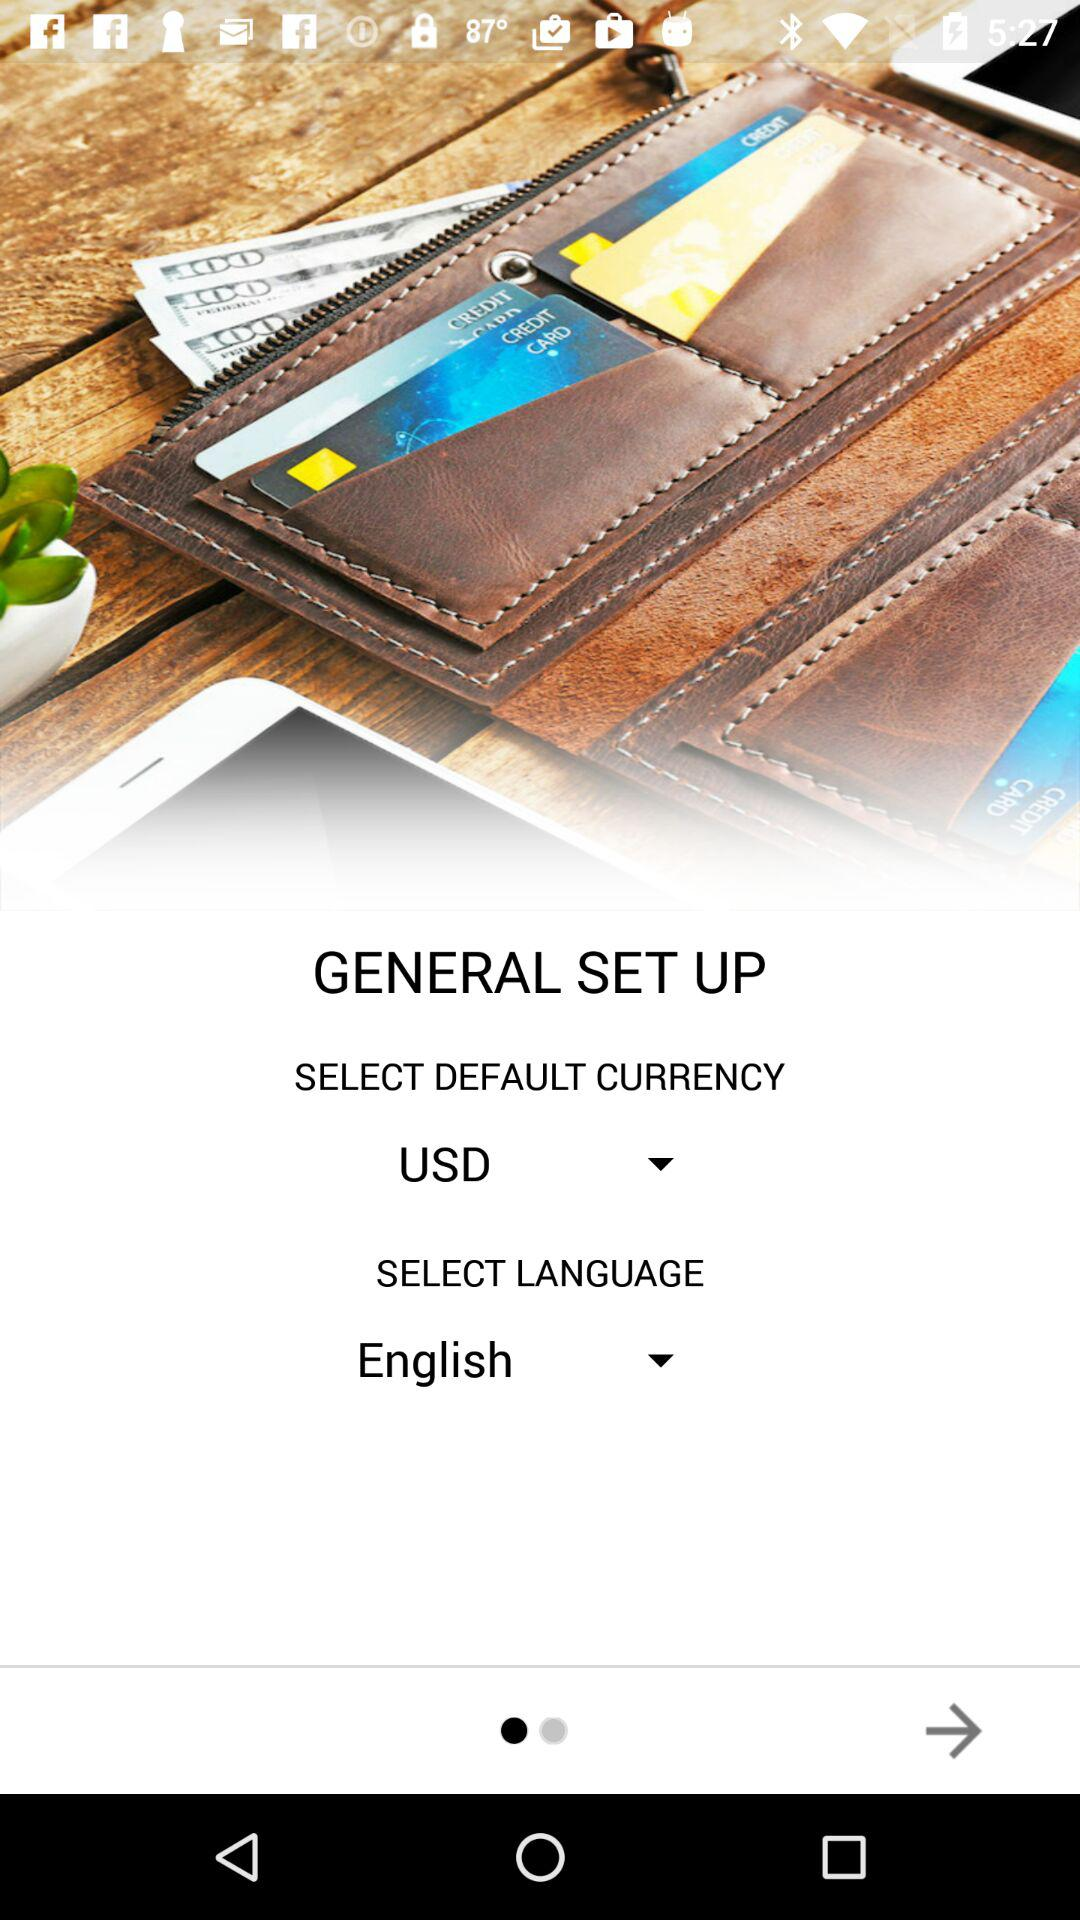What is the selected language? The selected language is English. 